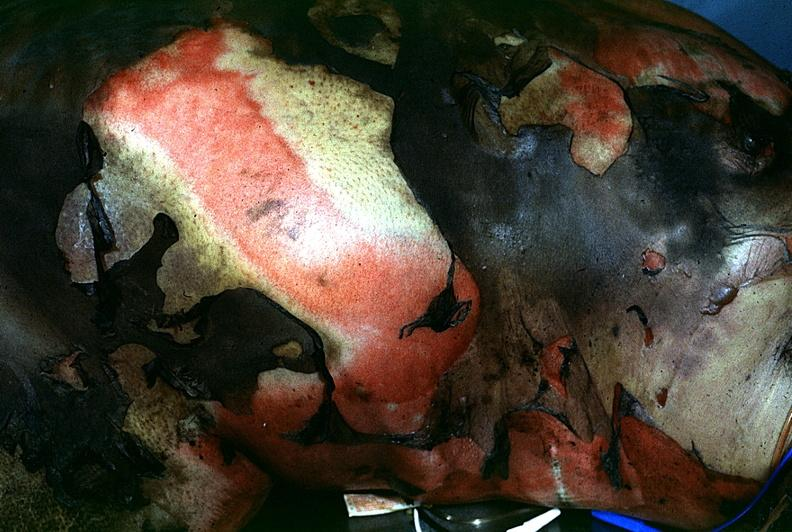what burn?
Answer the question using a single word or phrase. Thermal 